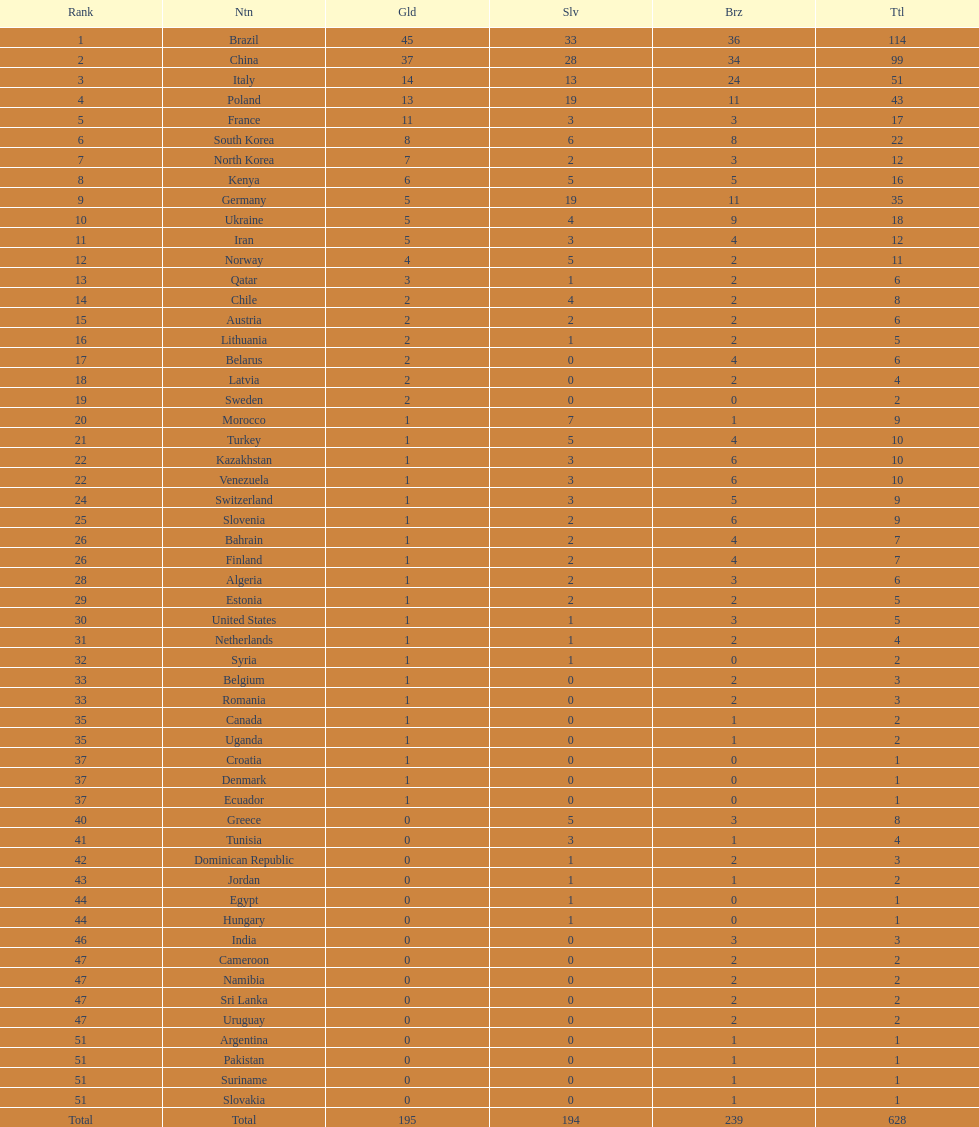How many more gold medals does china have over france? 26. 